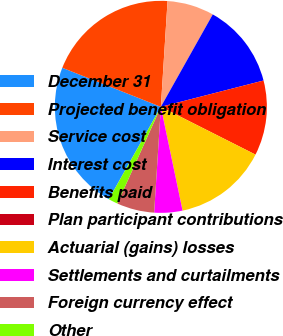<chart> <loc_0><loc_0><loc_500><loc_500><pie_chart><fcel>December 31<fcel>Projected benefit obligation<fcel>Service cost<fcel>Interest cost<fcel>Benefits paid<fcel>Plan participant contributions<fcel>Actuarial (gains) losses<fcel>Settlements and curtailments<fcel>Foreign currency effect<fcel>Other<nl><fcel>22.85%<fcel>20.0%<fcel>7.14%<fcel>12.86%<fcel>11.43%<fcel>0.0%<fcel>14.28%<fcel>4.29%<fcel>5.72%<fcel>1.43%<nl></chart> 